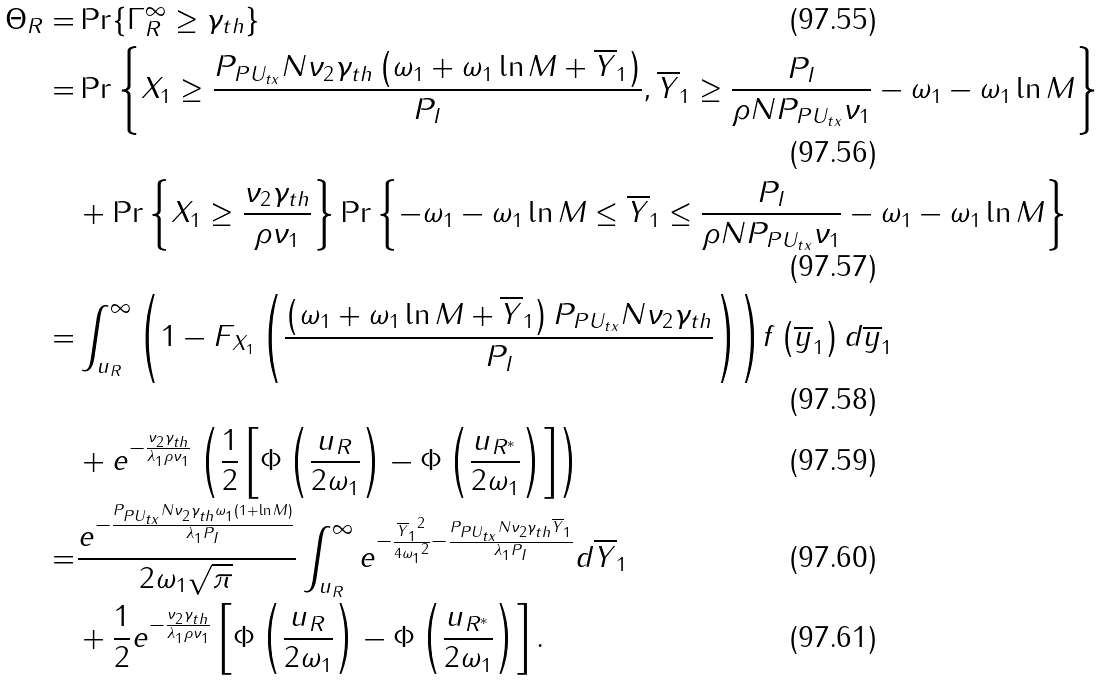Convert formula to latex. <formula><loc_0><loc_0><loc_500><loc_500>\Theta _ { R } = & \Pr \{ { \Gamma _ { R } ^ { \infty } } \geq { \gamma _ { t h } } \} \\ = & \Pr \left \{ { { X _ { 1 } } \geq \frac { { { P _ { P { U _ { t x } } } } N { \nu _ { 2 } } { \gamma _ { t h } } \left ( { { \omega _ { 1 } } + { \omega _ { 1 } } \ln M + { \overline { Y } _ { 1 } } } \right ) } } { P _ { I } } , { \overline { Y } _ { 1 } } \geq \frac { P _ { I } } { { \rho N { P _ { P { U _ { t x } } } } { \nu _ { 1 } } } } - { \omega _ { 1 } } - { \omega _ { 1 } } \ln M } \right \} \\ & + \Pr \left \{ { { X _ { 1 } } \geq \frac { { { \nu _ { 2 } } { \gamma _ { t h } } } } { { \rho { \nu _ { 1 } } } } } \right \} \Pr \left \{ { - { \omega _ { 1 } } - { \omega _ { 1 } } \ln M \leq { \overline { Y } _ { 1 } } \leq \frac { P _ { I } } { { \rho N { P _ { P { U _ { t x } } } } { \nu _ { 1 } } } } - { \omega _ { 1 } } - { \omega _ { 1 } } \ln M } \right \} \\ = & \int _ { u _ { R } } ^ { \infty } { \left ( { 1 - { F _ { X _ { 1 } } } \left ( { \frac { { \left ( { { \omega _ { 1 } } + { \omega _ { 1 } } \ln M + { { \overline { Y } _ { 1 } } } } \right ) { P _ { P { U _ { t x } } } } N { \nu _ { 2 } } { \gamma _ { t h } } } } { P _ { I } } } \right ) } \right ) } f \left ( { { { \overline { y } } _ { 1 } } } \right ) d { { \overline { y } } _ { 1 } } \\ & + { e ^ { - \frac { { { \nu _ { 2 } } { \gamma _ { t h } } } } { { { \lambda _ { 1 } } \rho { \nu _ { 1 } } } } } } \left ( { \frac { 1 } { 2 } \left [ { \Phi \left ( { \frac { u _ { R } } { { 2 { \omega _ { 1 } } } } } \right ) - \Phi \left ( { \frac { { { u _ { R ^ { * } } } } } { { 2 { \omega _ { 1 } } } } } \right ) } \right ] } \right ) \\ = & \frac { { { e ^ { - \frac { { { P _ { P { U _ { t x } } } } N { \nu _ { 2 } } { \gamma _ { t h } } { \omega _ { 1 } } \left ( { 1 + \ln M } \right ) } } { { { \lambda _ { 1 } } { P _ { I } } } } } } } } { { 2 { \omega _ { 1 } } \sqrt { \pi } } } \int _ { u _ { R } } ^ { \infty } { e ^ { - \frac { { { \overline { Y } _ { 1 } } ^ { 2 } } } { { 4 { \omega _ { 1 } } ^ { 2 } } } - \frac { { { P _ { P { U _ { t x } } } } N { \nu _ { 2 } } { \gamma _ { t h } } { \overline { Y } _ { 1 } } } } { { { \lambda _ { 1 } } { P _ { I } } } } } } d { \overline { Y } _ { 1 } } \\ & + \frac { 1 } { 2 } { e ^ { - \frac { { { \nu _ { 2 } } { \gamma _ { t h } } } } { { { \lambda _ { 1 } } \rho { \nu _ { 1 } } } } } } \left [ { \Phi \left ( { \frac { u _ { R } } { { 2 { \omega _ { 1 } } } } } \right ) - \Phi \left ( { \frac { { { u _ { R ^ { * } } } } } { { 2 { \omega _ { 1 } } } } } \right ) } \right ] .</formula> 